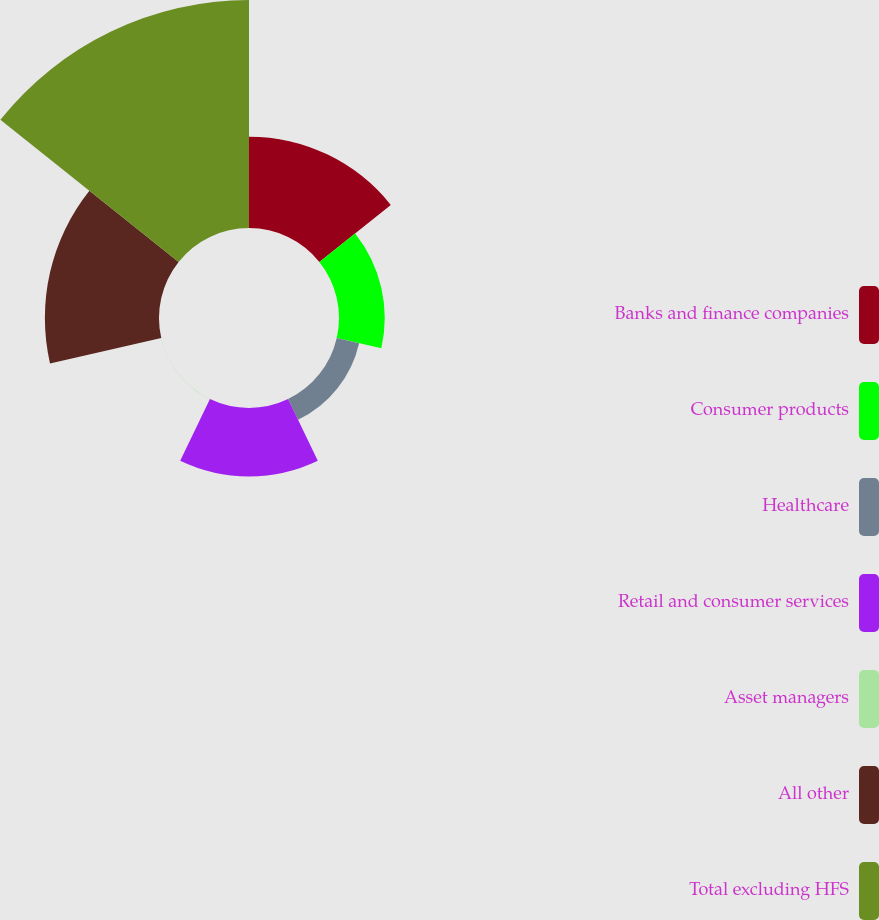Convert chart. <chart><loc_0><loc_0><loc_500><loc_500><pie_chart><fcel>Banks and finance companies<fcel>Consumer products<fcel>Healthcare<fcel>Retail and consumer services<fcel>Asset managers<fcel>All other<fcel>Total excluding HFS<nl><fcel>16.0%<fcel>8.01%<fcel>4.02%<fcel>12.01%<fcel>0.03%<fcel>19.99%<fcel>39.94%<nl></chart> 